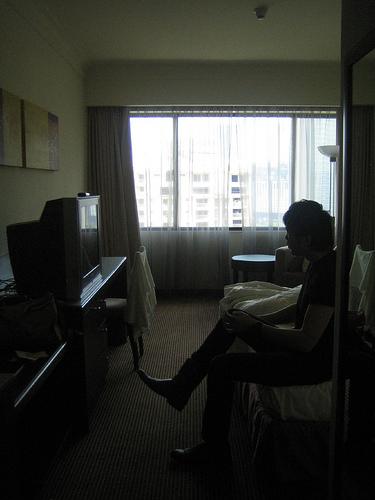Where is the man sitting?
Give a very brief answer. Bed. Is that a flat screen high definition television?
Give a very brief answer. No. Is this a hotel room?
Quick response, please. Yes. 